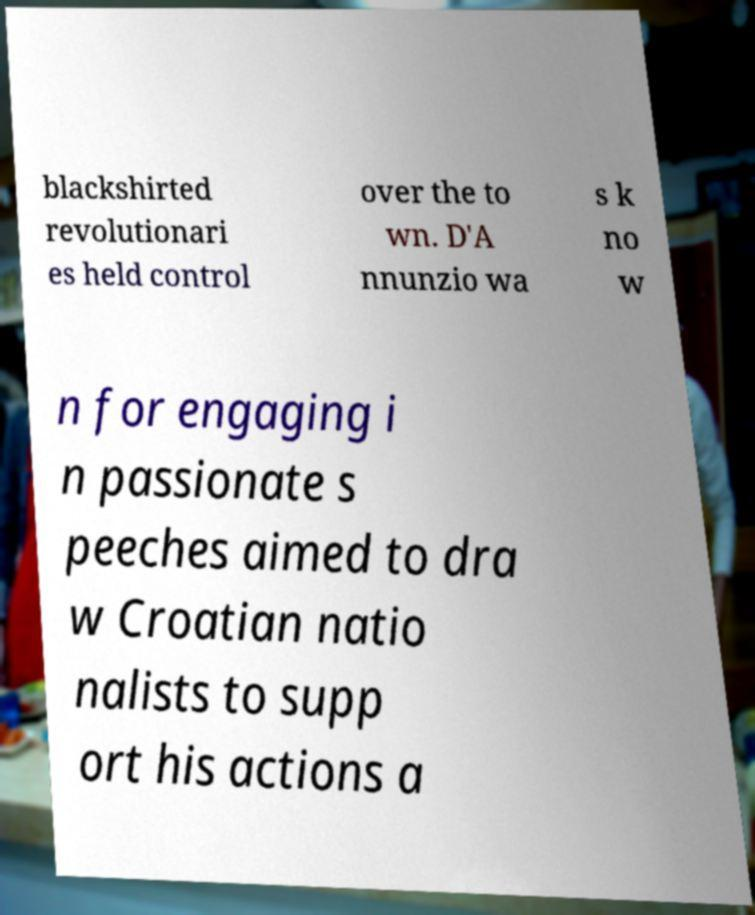For documentation purposes, I need the text within this image transcribed. Could you provide that? blackshirted revolutionari es held control over the to wn. D'A nnunzio wa s k no w n for engaging i n passionate s peeches aimed to dra w Croatian natio nalists to supp ort his actions a 